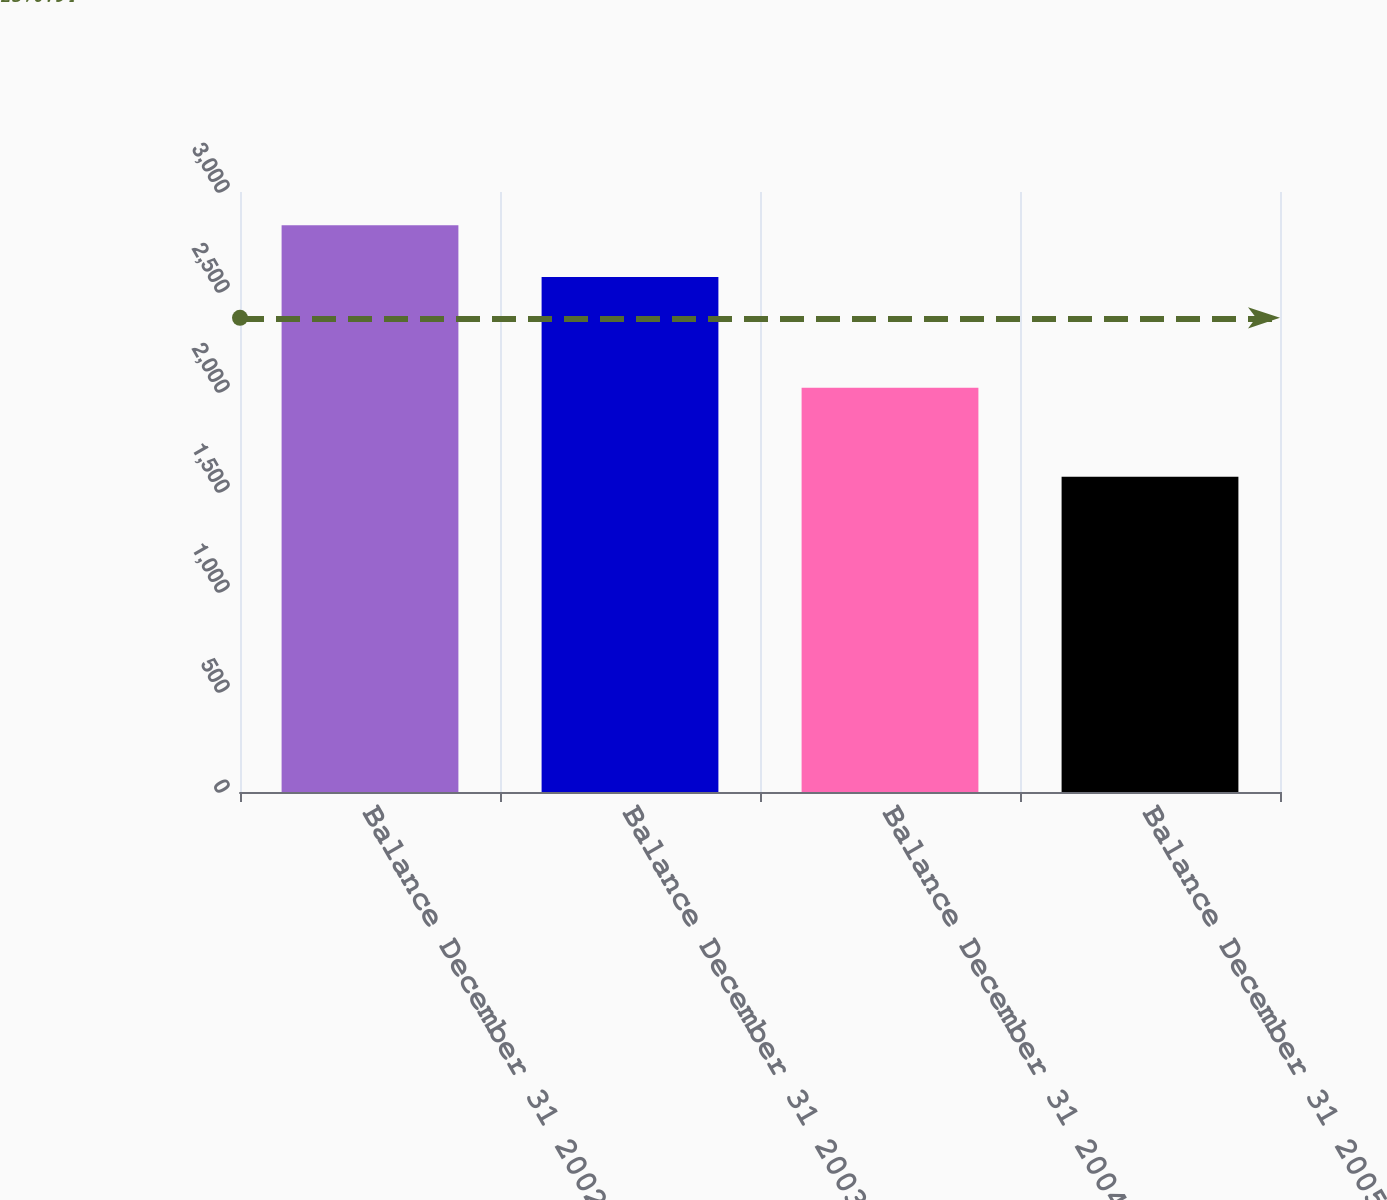Convert chart. <chart><loc_0><loc_0><loc_500><loc_500><bar_chart><fcel>Balance December 31 2002<fcel>Balance December 31 2003<fcel>Balance December 31 2004<fcel>Balance December 31 2005<nl><fcel>2834<fcel>2575<fcel>2021<fcel>1576<nl></chart> 